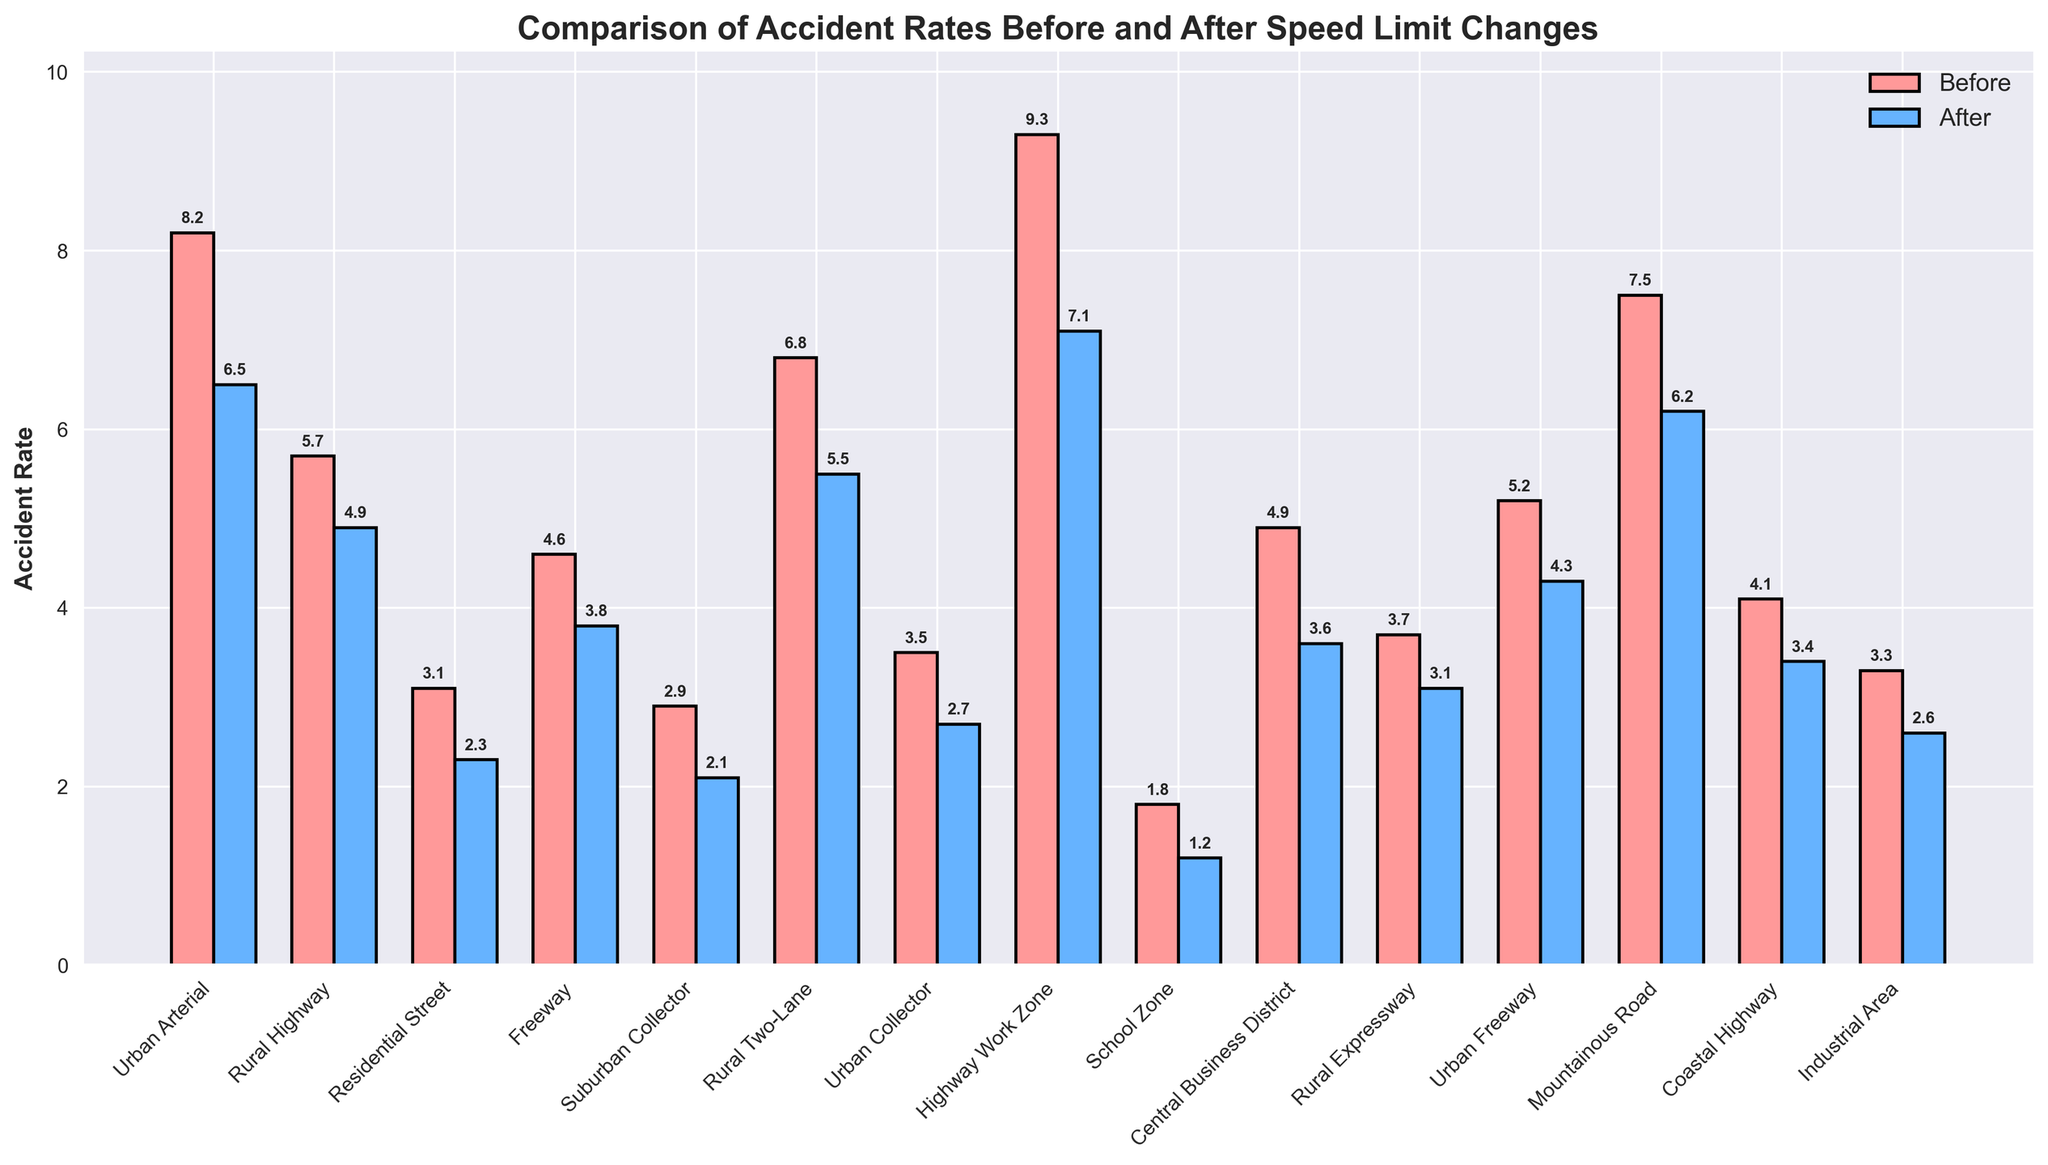Which road type had the highest accident rate before the speed limit change? The highest accident rate before the speed limit change can be identified by comparing the heights of the red bars. The highest bar corresponds to the "Highway Work Zone" with a rate of 9.3.
Answer: Highway Work Zone Which road type shows the greatest reduction in accident rate after the speed limit change? To find the greatest reduction, calculate the difference between the rates before and after the speed limit change for each road type. The "Highway Work Zone" shows the greatest reduction from 9.3 to 7.1, a decrease of 2.2.
Answer: Highway Work Zone What is the difference in accident rates before and after speed limit change for Urban Freeway? Subtract the accident rate after the change from the rate before the change for Urban Freeway. This is 5.2 - 4.3.
Answer: 0.9 Which road type has almost the same accident rates before and after the speed limit change? Look for bars that are almost equal in height for before and after changes. The "Rural Expressway" with rates of 3.7 and 3.1 has almost the same rates.
Answer: Rural Expressway What is the combined accident rate reduction for Urban Arterial and Rural Highway? Calculate the reduction for each road type (Urban Arterial: 8.2-6.5 = 1.7, Rural Highway: 5.7-4.9 = 0.8) and sum them up: 1.7 + 0.8.
Answer: 2.5 By how much did the accident rate in School Zone decrease? Subtract the after rate from the before rate for School Zone: 1.8 - 1.2.
Answer: 0.6 Which road type had the highest accident rate reduction in a residential area? Identify road types relevant to residential areas, e.g., Residential Street and compare the reduction: 3.1 - 2.3.
Answer: 0.8 How many road types have an accident rate below 3.0 after the speed limit change? Count the bars representing the accident rates after the speed limit change that are below 3.0. There are "Residential Street", "Suburban Collector", "Urban Collector", "School Zone", "Central Business District", "Rural Expressway", and "Industrial Area".
Answer: 7 